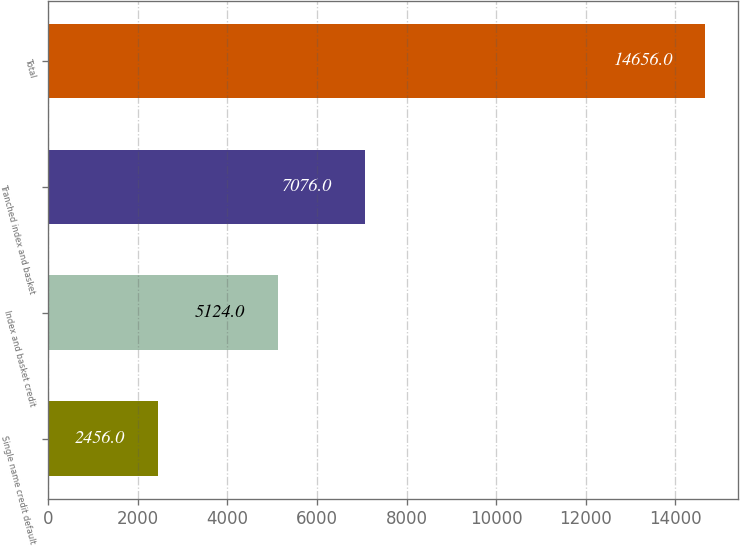Convert chart to OTSL. <chart><loc_0><loc_0><loc_500><loc_500><bar_chart><fcel>Single name credit default<fcel>Index and basket credit<fcel>Tranched index and basket<fcel>Total<nl><fcel>2456<fcel>5124<fcel>7076<fcel>14656<nl></chart> 